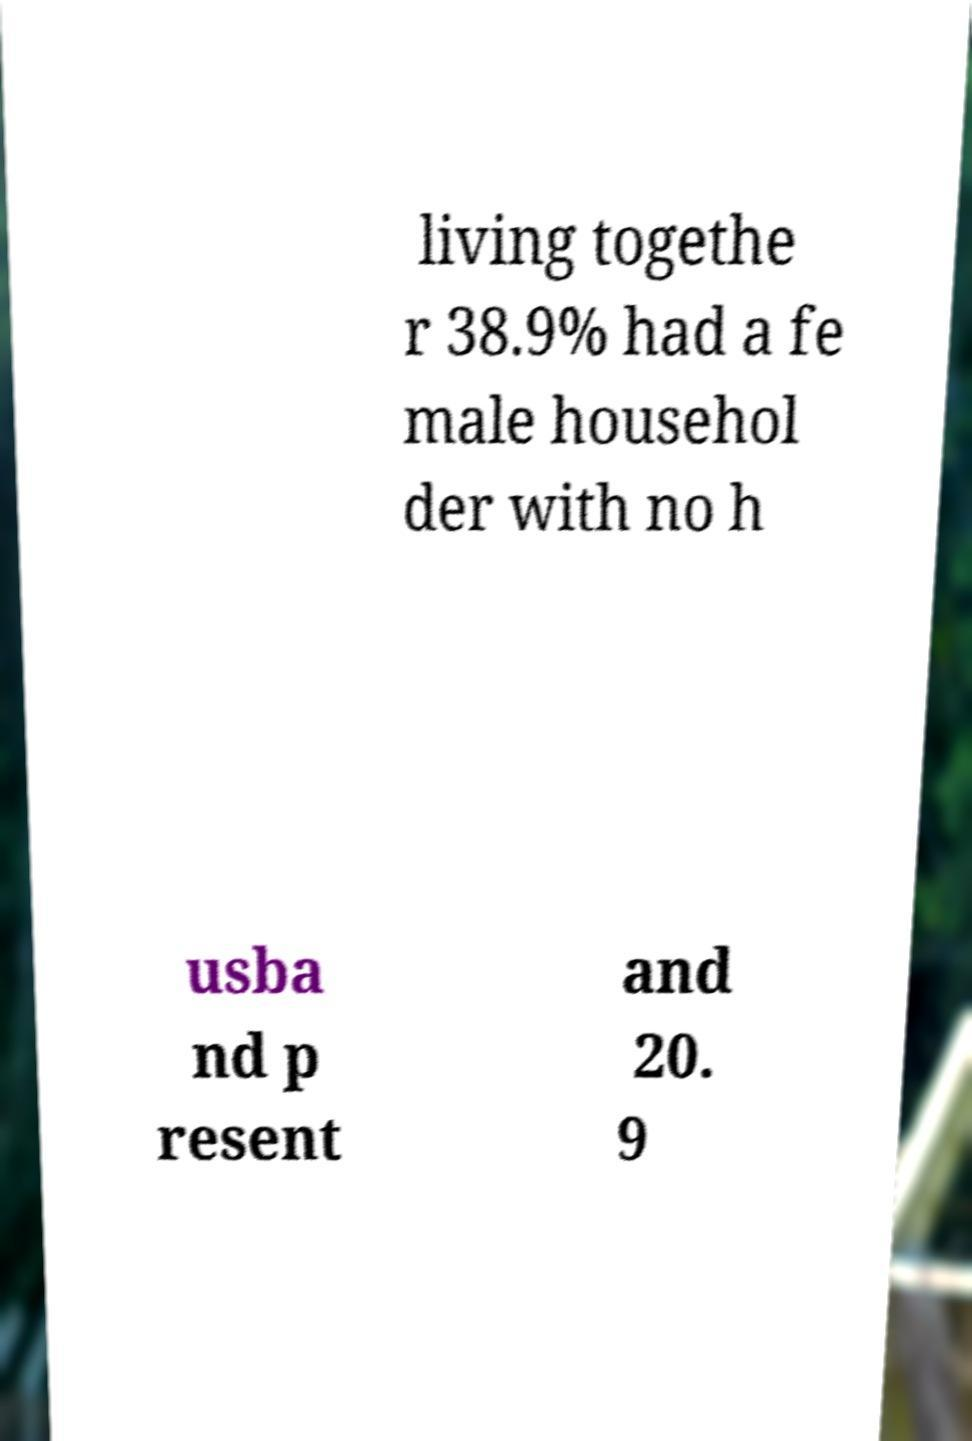There's text embedded in this image that I need extracted. Can you transcribe it verbatim? living togethe r 38.9% had a fe male househol der with no h usba nd p resent and 20. 9 